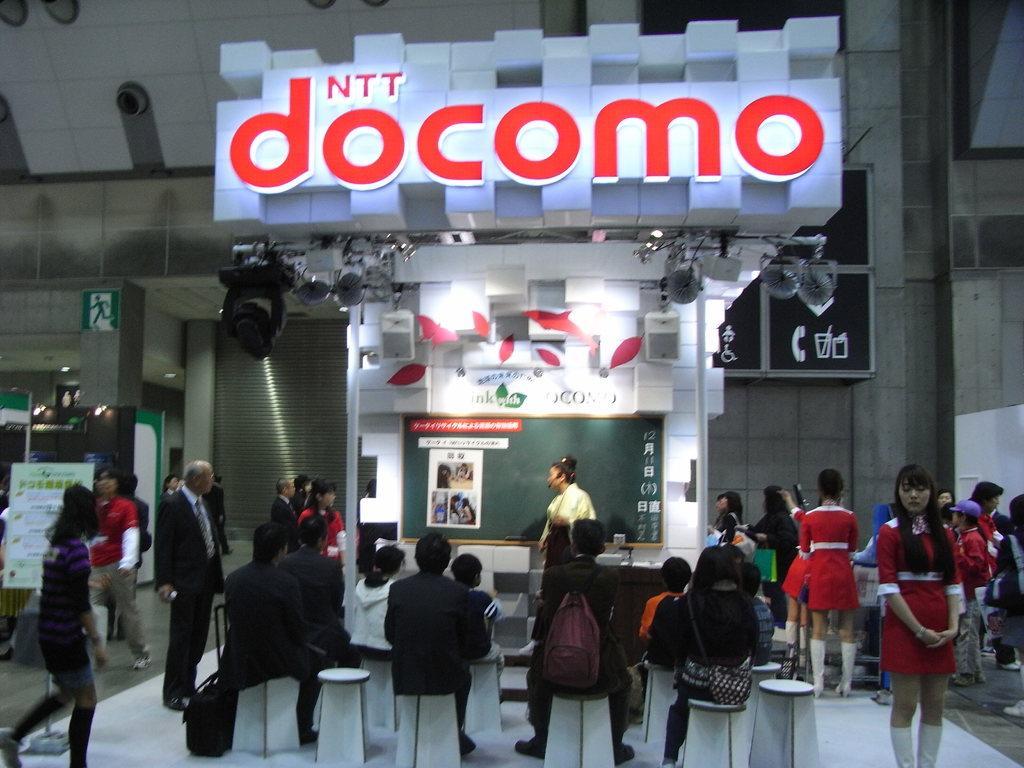How would you summarize this image in a sentence or two? In this picture we can see people. Few of them are sitting, standing and walking. We can see a sign board at the top. We can see lights, boards, pictures and devices. We can see a person wearing a mic and explaining something, standing near to a board. 